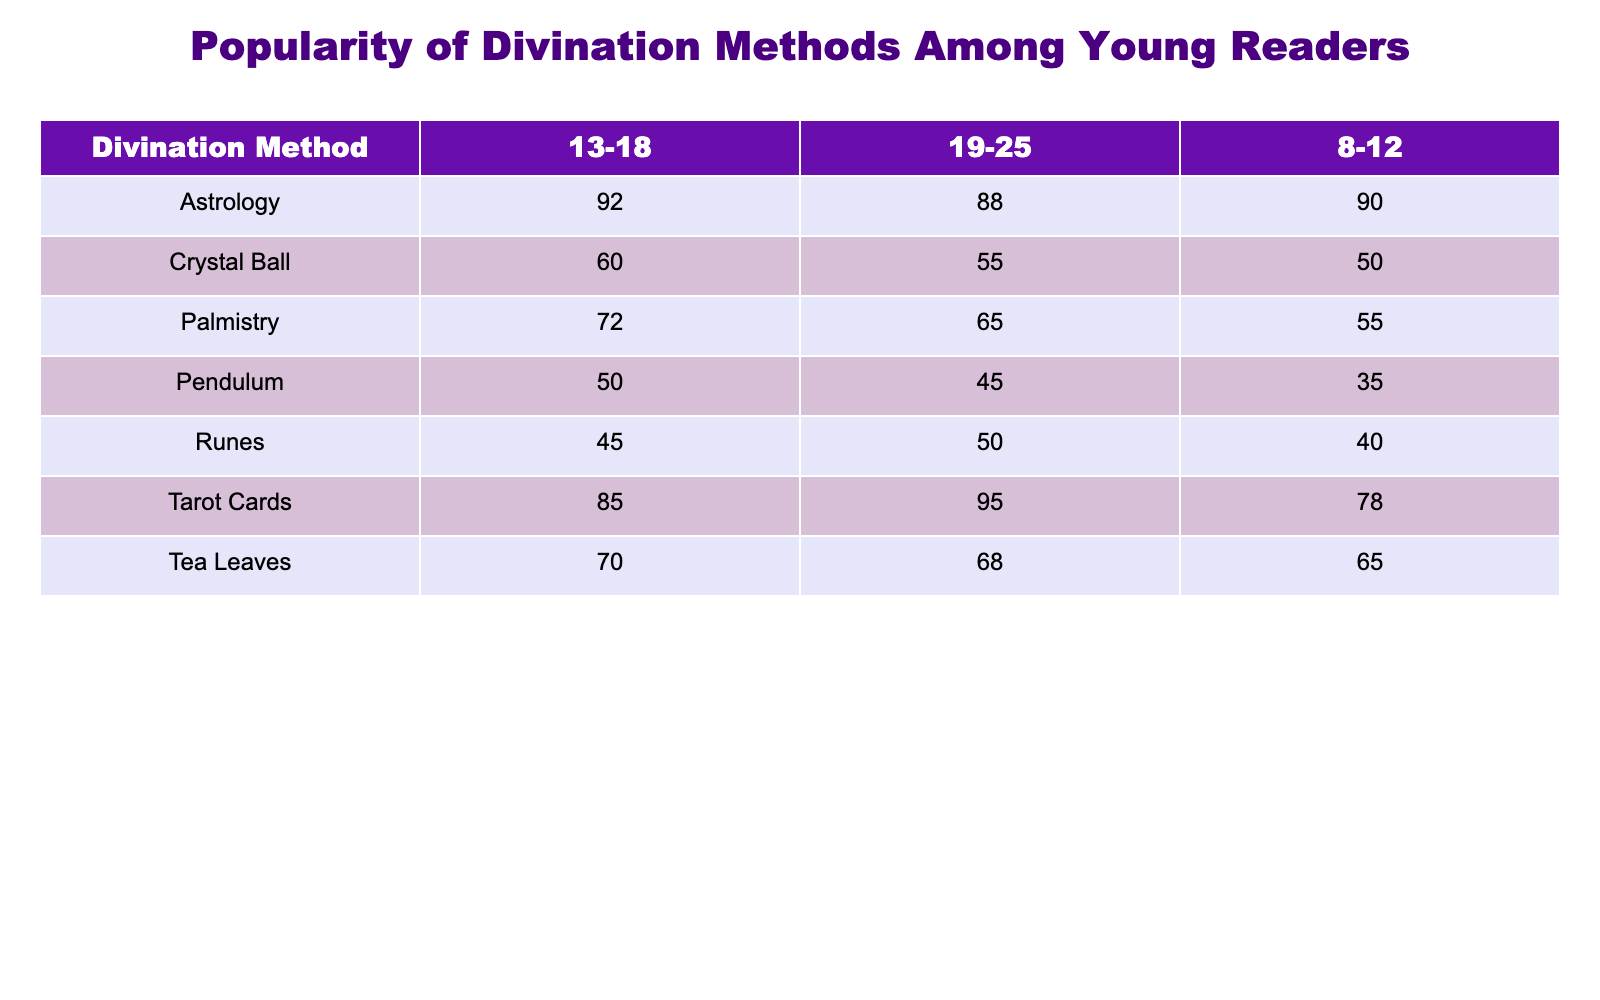What is the popularity score of Tarot Cards among the 13-18 age group? According to the table, the popularity score for Tarot Cards in the 13-18 age group is directly listed as 85.
Answer: 85 Which divination method has the highest popularity score among the 8-12 age group? Referring to the table, Astrology has a popularity score of 90, which is higher than any other method in the 8-12 age group.
Answer: Astrology Is the popularity score of Crystal Ball higher among the 19-25 age group than among the 8-12 age group? The table shows a popularity score of 55 for Crystal Ball in the 19-25 age group and 50 in the 8-12 age group. Since 55 is greater than 50, the answer is yes.
Answer: Yes What is the average popularity score for Tea Leaves across all age groups? The table lists the scores for Tea Leaves as 65 (8-12), 70 (13-18), and 68 (19-25). To find the average, add them: 65 + 70 + 68 = 203. Then divide by 3 to get the average: 203 / 3 = approximately 67.67.
Answer: 67.67 Which age group shows the most significant drop in the popularity score of Pendulum compared to the age group with the highest score? The Pendulum has scores of 35 (8-12), 50 (13-18), and 45 (19-25). The highest score is 92 (Astrology in 13-18 age group). The drop from 35 to 50 is 15, and from 50 to 45 is 5. The most significant drop is from 35 to 50 among the 8-12 age group, showing 15.
Answer: 15 Is there any divination method that remains consistent in its popularity score across all age groups? By examining the table, we observe that no single divination method has the same popularity score across all age groups; each method has different values. Thus, the answer is no.
Answer: No What is the difference in popularity scores between Astrology and Runes for the 13-18 age group? For Astrology, the score is 92 and for Runes, it is 45 in the 13-18 age group. To find the difference, subtract the lower score from the higher score: 92 - 45 = 47.
Answer: 47 Which divination method has the lowest popularity score among young readers overall? The minimum scores across all age groups are Pendulum with 35 (8-12), 50 (13-18), and 45 (19-25). Therefore, Pendulum has the lowest overall popularity score at 35.
Answer: Pendulum 